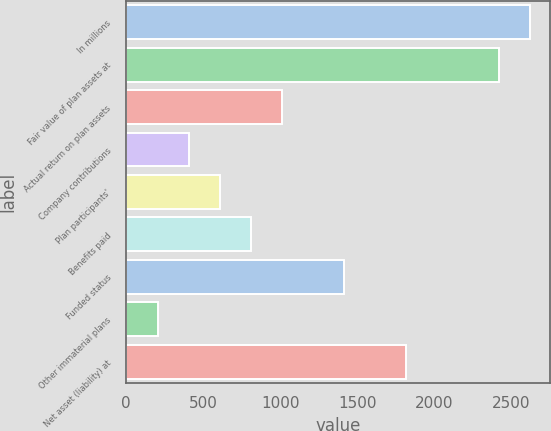Convert chart to OTSL. <chart><loc_0><loc_0><loc_500><loc_500><bar_chart><fcel>In millions<fcel>Fair value of plan assets at<fcel>Actual return on plan assets<fcel>Company contributions<fcel>Plan participants'<fcel>Benefits paid<fcel>Funded status<fcel>Other immaterial plans<fcel>Net asset (liability) at<nl><fcel>2620.9<fcel>2419.6<fcel>1010.5<fcel>406.6<fcel>607.9<fcel>809.2<fcel>1413.1<fcel>205.3<fcel>1815.7<nl></chart> 